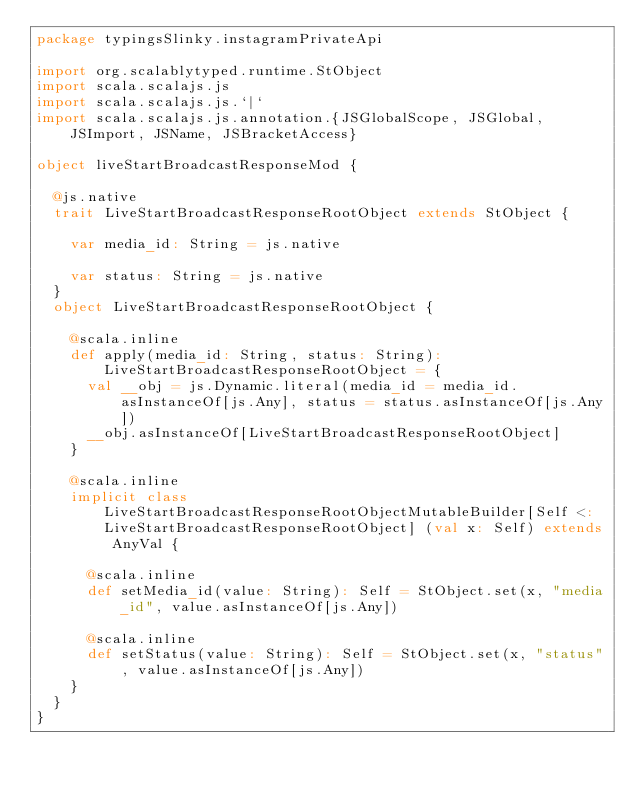Convert code to text. <code><loc_0><loc_0><loc_500><loc_500><_Scala_>package typingsSlinky.instagramPrivateApi

import org.scalablytyped.runtime.StObject
import scala.scalajs.js
import scala.scalajs.js.`|`
import scala.scalajs.js.annotation.{JSGlobalScope, JSGlobal, JSImport, JSName, JSBracketAccess}

object liveStartBroadcastResponseMod {
  
  @js.native
  trait LiveStartBroadcastResponseRootObject extends StObject {
    
    var media_id: String = js.native
    
    var status: String = js.native
  }
  object LiveStartBroadcastResponseRootObject {
    
    @scala.inline
    def apply(media_id: String, status: String): LiveStartBroadcastResponseRootObject = {
      val __obj = js.Dynamic.literal(media_id = media_id.asInstanceOf[js.Any], status = status.asInstanceOf[js.Any])
      __obj.asInstanceOf[LiveStartBroadcastResponseRootObject]
    }
    
    @scala.inline
    implicit class LiveStartBroadcastResponseRootObjectMutableBuilder[Self <: LiveStartBroadcastResponseRootObject] (val x: Self) extends AnyVal {
      
      @scala.inline
      def setMedia_id(value: String): Self = StObject.set(x, "media_id", value.asInstanceOf[js.Any])
      
      @scala.inline
      def setStatus(value: String): Self = StObject.set(x, "status", value.asInstanceOf[js.Any])
    }
  }
}
</code> 